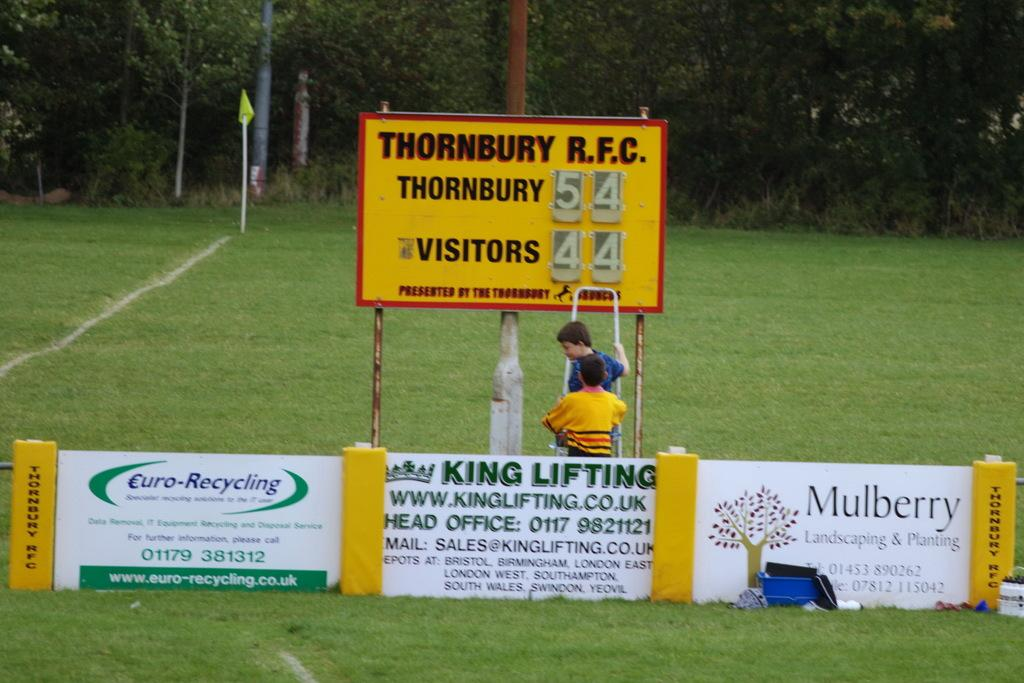<image>
Present a compact description of the photo's key features. A scoreboard for Thornbury R.F.C. shows a score of 54 to 44. 